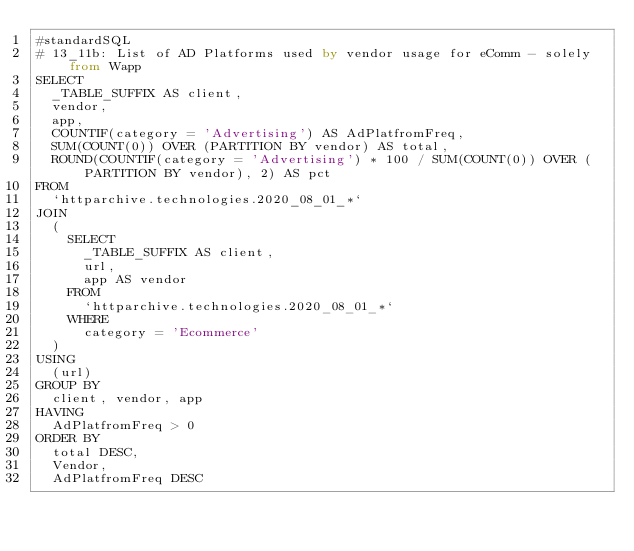<code> <loc_0><loc_0><loc_500><loc_500><_SQL_>#standardSQL
# 13_11b: List of AD Platforms used by vendor usage for eComm - solely from Wapp
SELECT
  _TABLE_SUFFIX AS client,
  vendor,
  app,
  COUNTIF(category = 'Advertising') AS AdPlatfromFreq,
  SUM(COUNT(0)) OVER (PARTITION BY vendor) AS total,
  ROUND(COUNTIF(category = 'Advertising') * 100 / SUM(COUNT(0)) OVER (PARTITION BY vendor), 2) AS pct
FROM
  `httparchive.technologies.2020_08_01_*`
JOIN
  (
    SELECT
      _TABLE_SUFFIX AS client,
      url,
      app AS vendor
    FROM
      `httparchive.technologies.2020_08_01_*`
    WHERE
      category = 'Ecommerce'
  )
USING
  (url)
GROUP BY
  client, vendor, app
HAVING
  AdPlatfromFreq > 0
ORDER BY
  total DESC,
  Vendor,
  AdPlatfromFreq DESC
</code> 